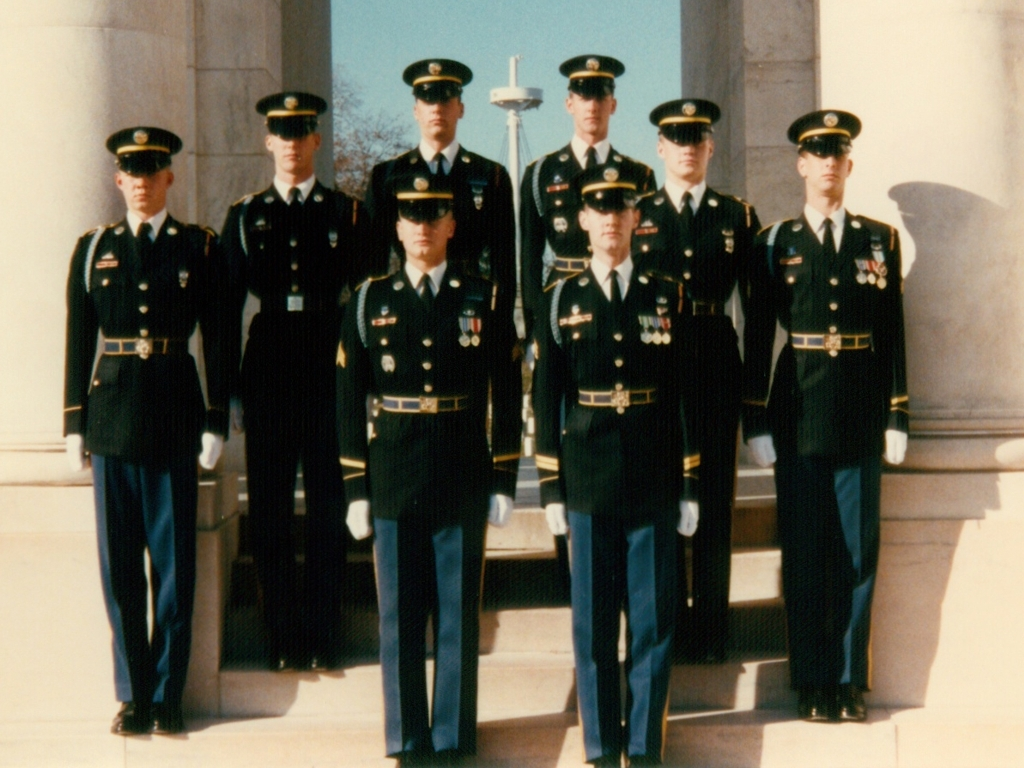Can you tell me what sort of event this might be a photo of? This appears to be a photo from a formal military event, possibly a ceremonial function given the uniformity and decorum of the individuals' uniforms and the medals displayed. What details in their uniforms stand out to you? Their uniforms are crisp and well-maintained, showcasing various medals and ribbons that reflect commendable service. The white gloves and regimented positioning convey a sense of discipline and order. 